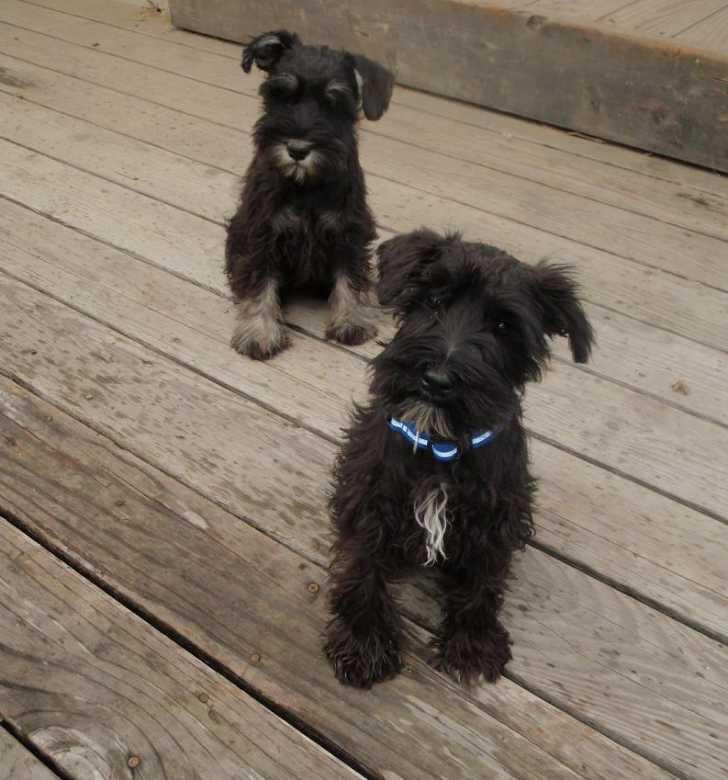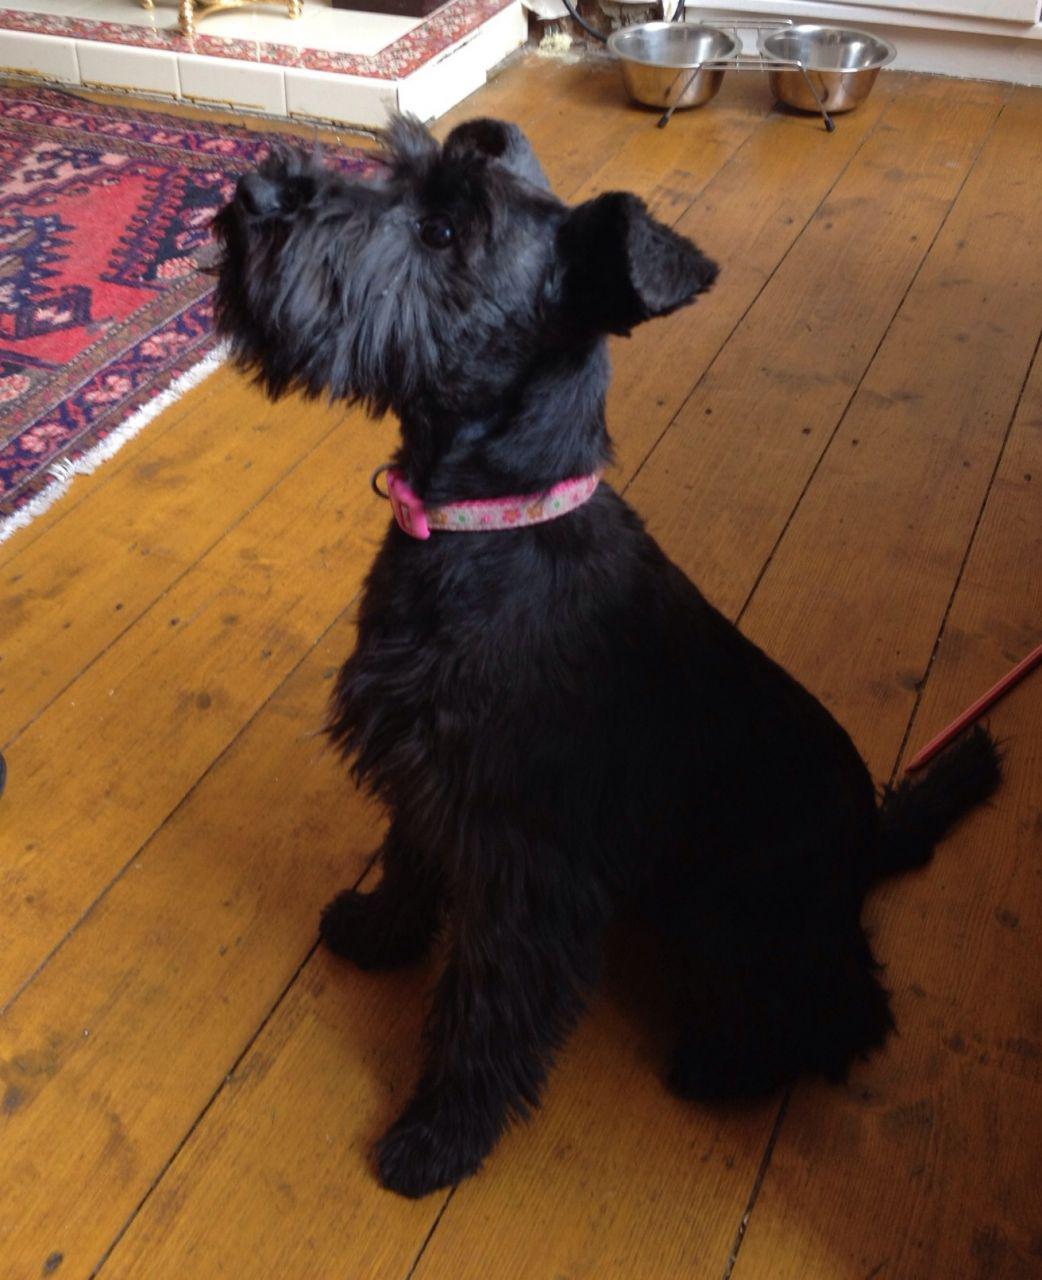The first image is the image on the left, the second image is the image on the right. For the images shown, is this caption "One of the images has two dogs that are sitting." true? Answer yes or no. Yes. The first image is the image on the left, the second image is the image on the right. For the images shown, is this caption "There are at most two dogs." true? Answer yes or no. No. 